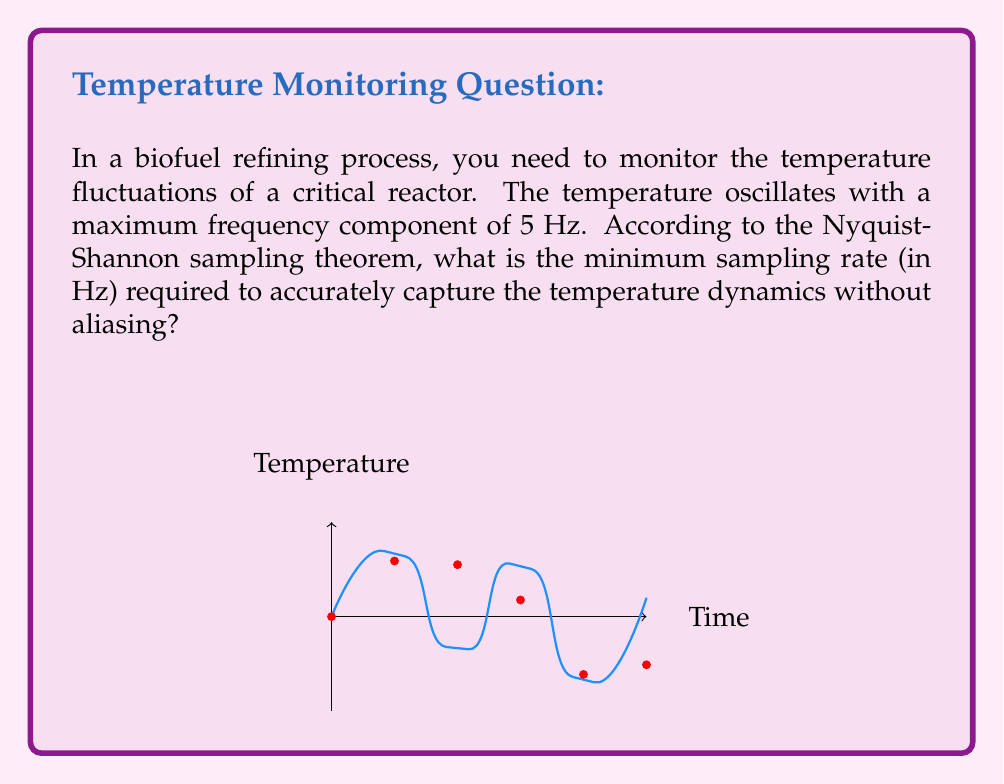Can you solve this math problem? To determine the optimal sampling rate, we need to apply the Nyquist-Shannon sampling theorem. This theorem states that to accurately reconstruct a continuous-time signal from its samples, the sampling rate must be at least twice the highest frequency component in the signal.

Given:
- The maximum frequency component in the temperature fluctuations is 5 Hz.

Step 1: Apply the Nyquist-Shannon sampling theorem
$$ f_s \geq 2f_{max} $$
Where:
$f_s$ = sampling rate
$f_{max}$ = maximum frequency component in the signal

Step 2: Calculate the minimum sampling rate
$$ f_s \geq 2 \cdot 5\text{ Hz} $$
$$ f_s \geq 10\text{ Hz} $$

Therefore, the minimum sampling rate required to accurately capture the temperature dynamics without aliasing is 10 Hz.

In practice, it's often recommended to sample at a rate higher than the Nyquist rate to account for non-ideal filtering and to improve the signal-to-noise ratio. A common rule of thumb is to sample at 2.5 to 4 times the Nyquist rate.
Answer: 10 Hz 